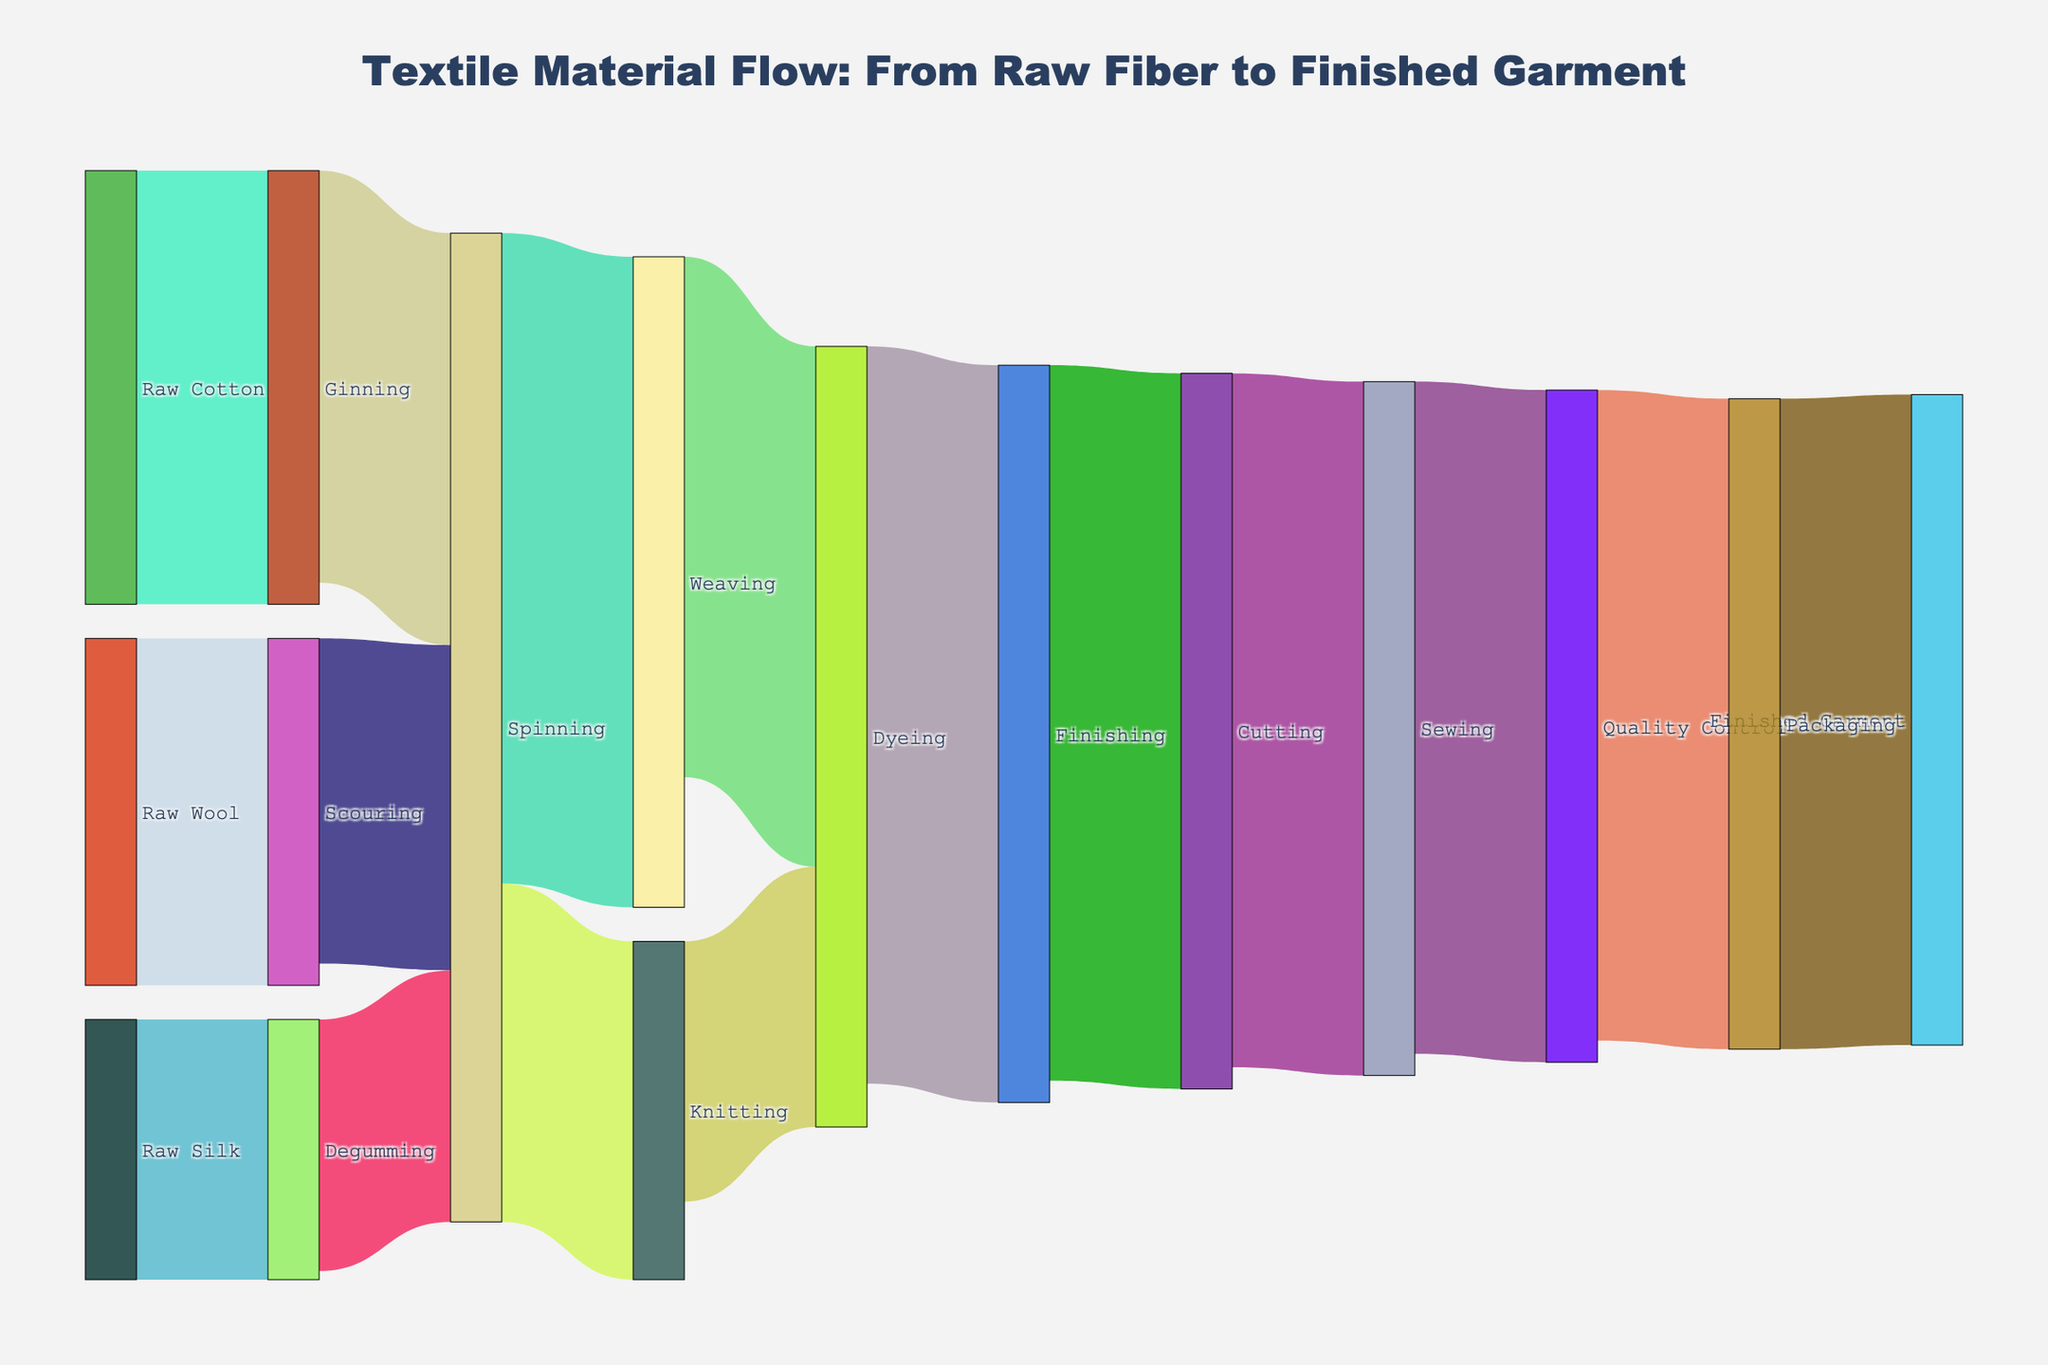What are the main raw materials used in the textile material flow? From the figure, you can see the starting points for the flow. These include Raw Cotton, Raw Wool, and Raw Silk.
Answer: Raw Cotton, Raw Wool, Raw Silk Which processing stage receives the highest quantity of materials from prior stages? Look at the connections between stages and sum the values flowing into each stage. Dyeing receives 1200 from Weaving and 600 from Knitting, totaling 1800.
Answer: Dyeing How much material moves from Spinning to Knitting? Follow the link from Spinning to Knitting and observe the numerical value on the link that indicates the material flow quantity.
Answer: 780 Compare the quantity of material flowing from Ginning to Spinning with the quantity from Scouring to Spinning. Which one is larger? Check the numerical values on the links from Ginning to Spinning (950) and Scouring to Spinning (750). Compare the two values to see which is larger.
Answer: Ginning to Spinning What are the final stages before the finished garment? List them in order. Trace the flow from the start to the finished garment. The final stages are Packaging, which is fed by Quality Control, fed by Sewing, fed by Cutting, fed by Finishing.
Answer: Packaging, Quality Control, Sewing, Cutting, Finishing Which processing stage has the least material passing through it? Identify and compare the numerical values for each flow. Degumming, with a flow of 600 to Spinning, has the least material.
Answer: Degumming What total amount of material is fed into Spinning? Add up the material quantities from Ginning (950), Scouring (750), and Degumming (580) that go into Spinning. So, 950 + 750 + 580 = 2280.
Answer: 2280 Is the quantity of material flowing into Weaving greater than the quantity flowing into Knitting? Observe the values flowing into Weaving (1500) and Knitting (780). Compare them to see which is larger.
Answer: Yes, greater Which stage has almost all its processed material moving to the next stage without much loss? Observe the inflow and outflow values for each stage. For example, nearly all the Dyeing material (1700) moves to Finishing (1650).
Answer: Dyeing How much material is processed in the final Packaging stage before becoming a finished garment? Look at the value on the link between Packaging and Finished Garment.
Answer: 1500 